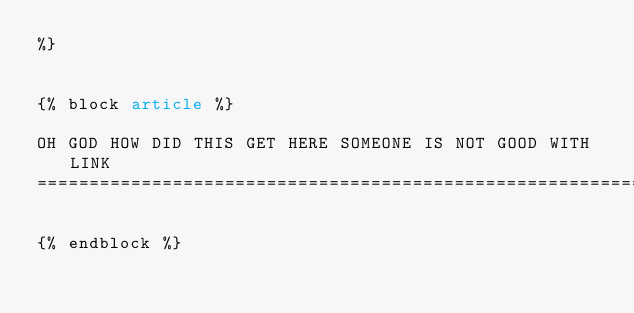Convert code to text. <code><loc_0><loc_0><loc_500><loc_500><_HTML_>%}


{% block article %}

OH GOD HOW DID THIS GET HERE SOMEONE IS NOT GOOD WITH LINK
==========================================================

{% endblock %}
</code> 